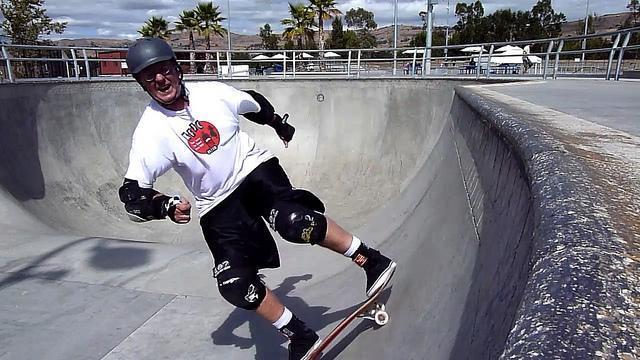How many cars are on the monorail?
Give a very brief answer. 0. 